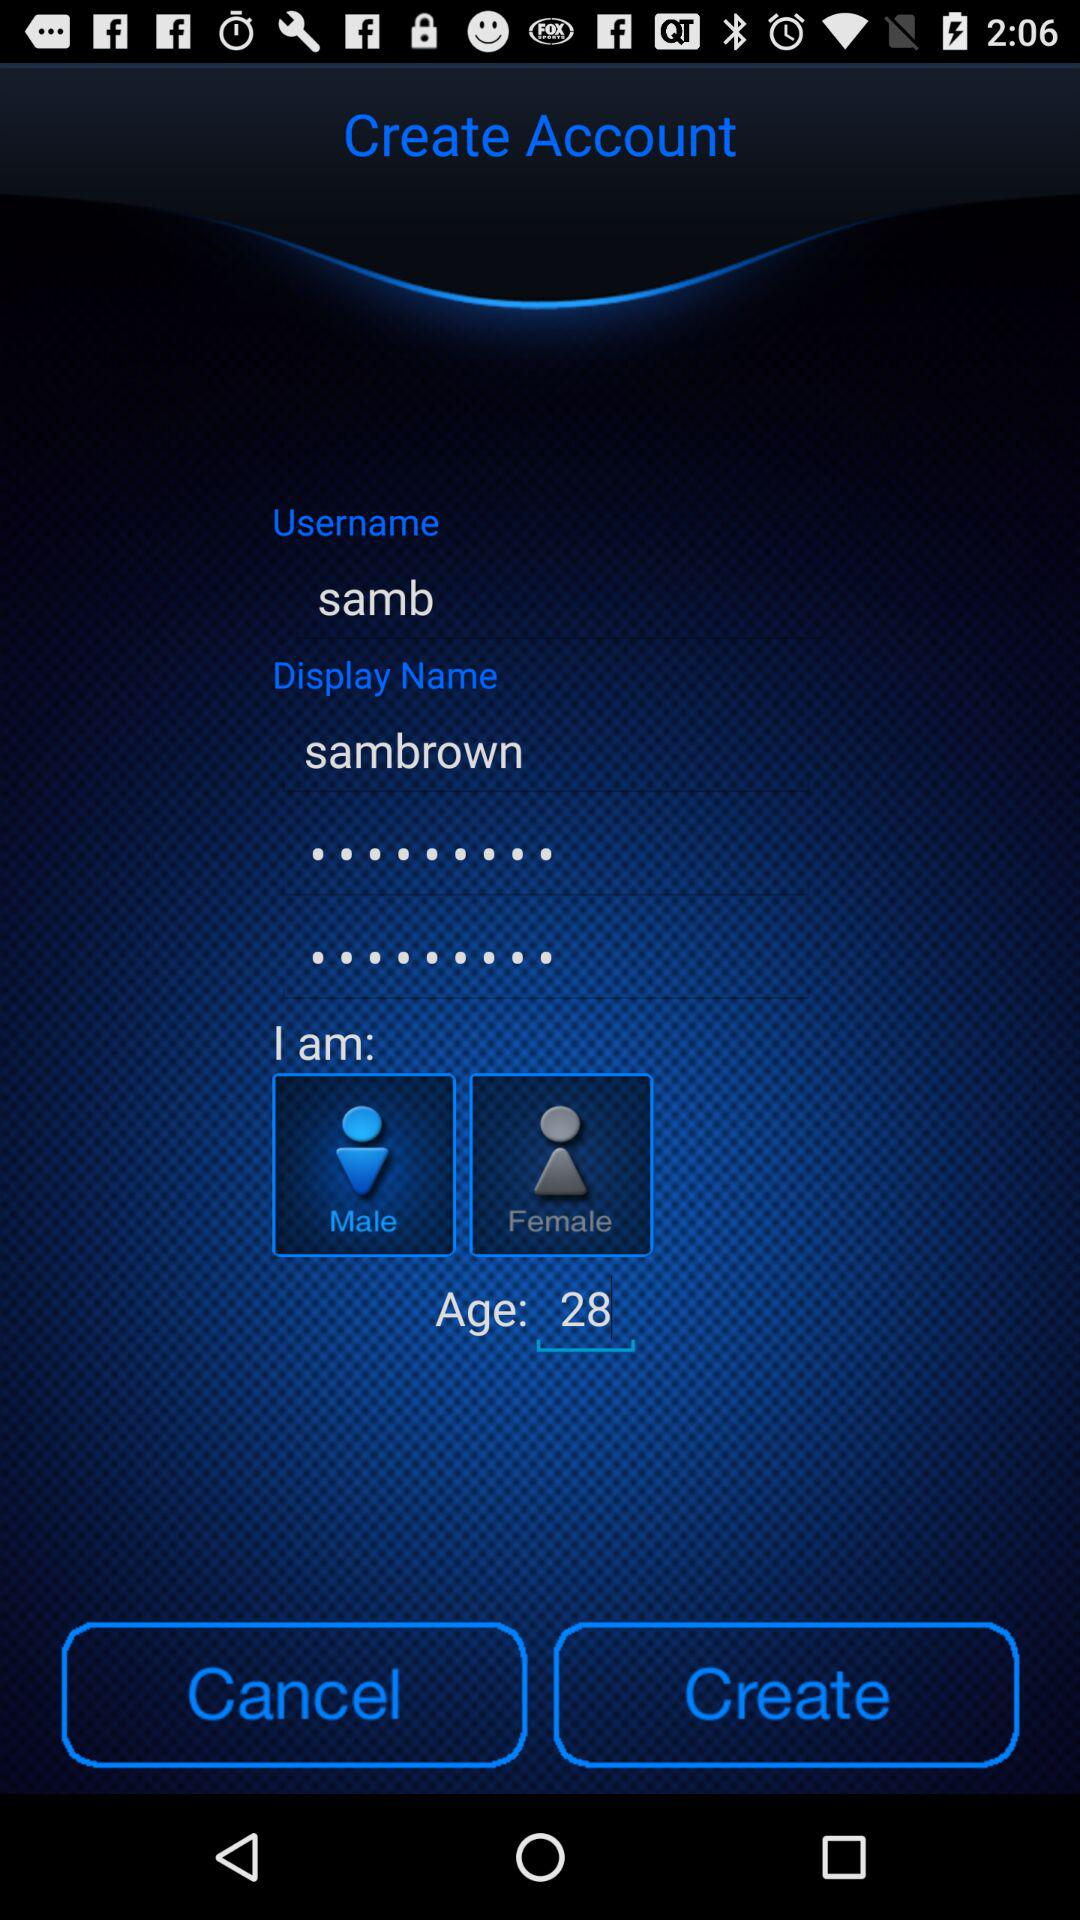What is the user name? The user name is "samb". 